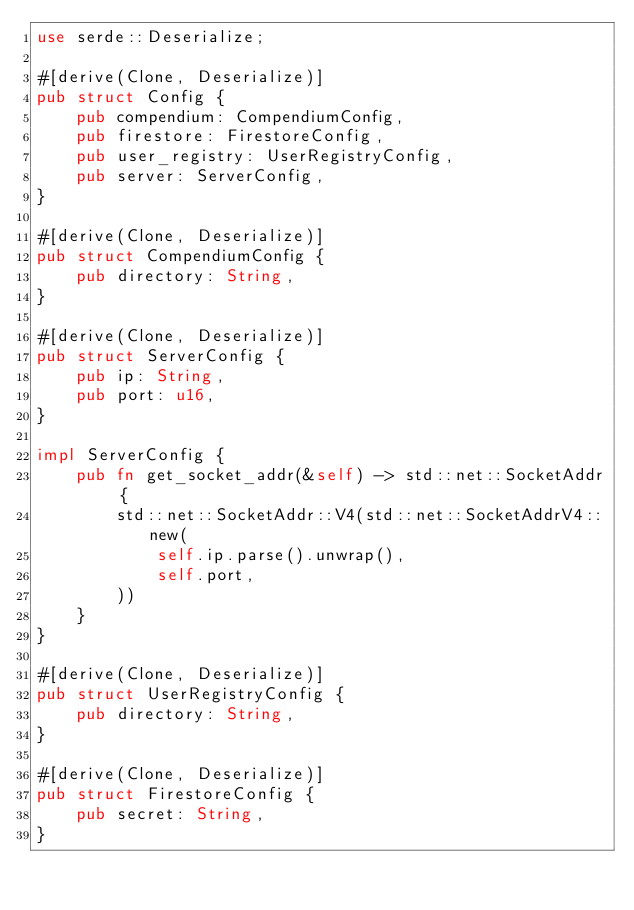<code> <loc_0><loc_0><loc_500><loc_500><_Rust_>use serde::Deserialize;

#[derive(Clone, Deserialize)]
pub struct Config {
    pub compendium: CompendiumConfig,
    pub firestore: FirestoreConfig,
    pub user_registry: UserRegistryConfig,
    pub server: ServerConfig,
}

#[derive(Clone, Deserialize)]
pub struct CompendiumConfig {
    pub directory: String,
}

#[derive(Clone, Deserialize)]
pub struct ServerConfig {
    pub ip: String,
    pub port: u16,
}

impl ServerConfig {
    pub fn get_socket_addr(&self) -> std::net::SocketAddr {
        std::net::SocketAddr::V4(std::net::SocketAddrV4::new(
            self.ip.parse().unwrap(),
            self.port,
        ))
    }
}

#[derive(Clone, Deserialize)]
pub struct UserRegistryConfig {
    pub directory: String,
}

#[derive(Clone, Deserialize)]
pub struct FirestoreConfig {
    pub secret: String,
}
</code> 